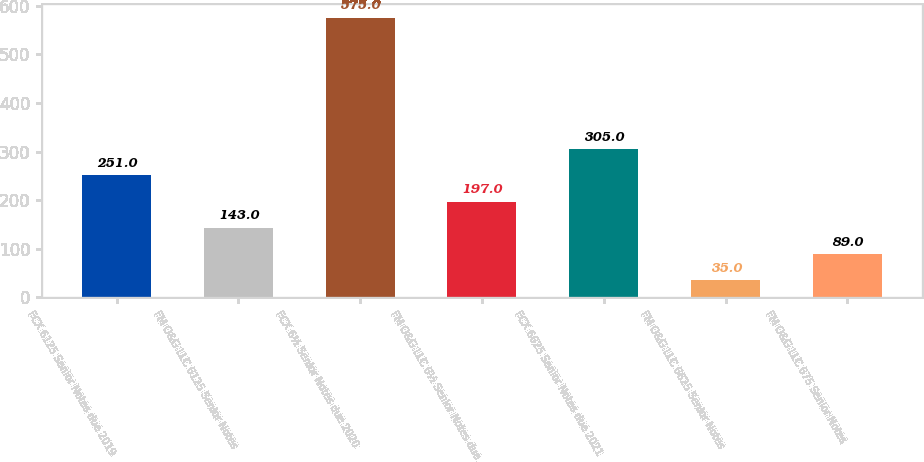Convert chart. <chart><loc_0><loc_0><loc_500><loc_500><bar_chart><fcel>FCX 6125 Senior Notes due 2019<fcel>FM O&G LLC 6125 Senior Notes<fcel>FCX 6½ Senior Notes due 2020<fcel>FM O&G LLC 6½ Senior Notes due<fcel>FCX 6625 Senior Notes due 2021<fcel>FM O&G LLC 6625 Senior Notes<fcel>FM O&G LLC 675 Senior Notes<nl><fcel>251<fcel>143<fcel>575<fcel>197<fcel>305<fcel>35<fcel>89<nl></chart> 